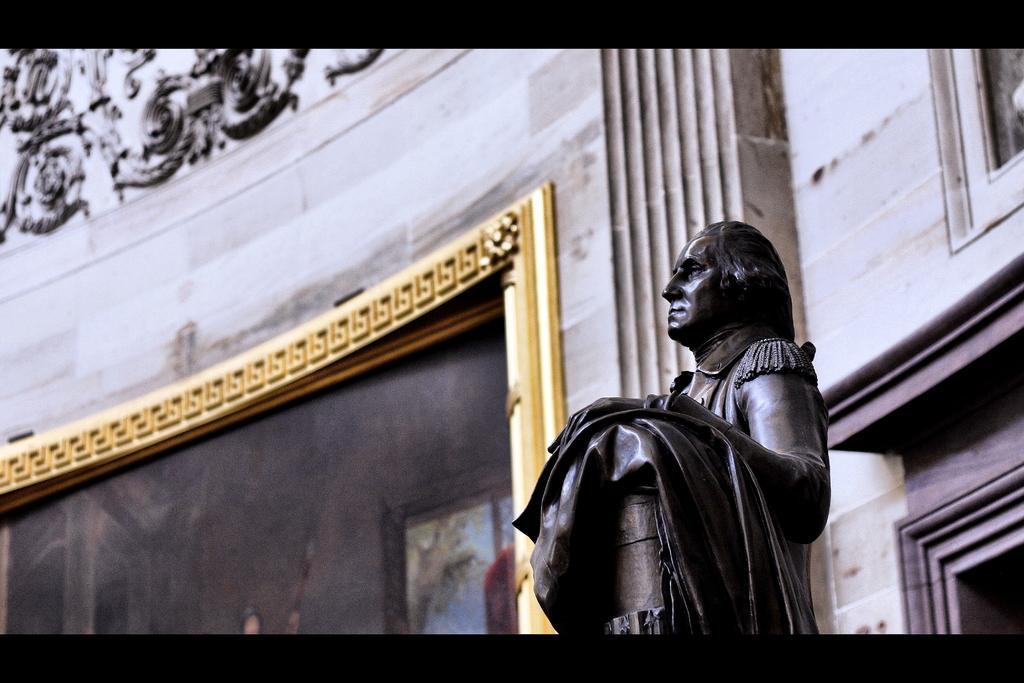Can you describe this image briefly? In this image I see the wall and I see designs over here and I see a sculpture of a man over here, which is of black in color and I see the frame over here which is of golden in color and I see a picture. 